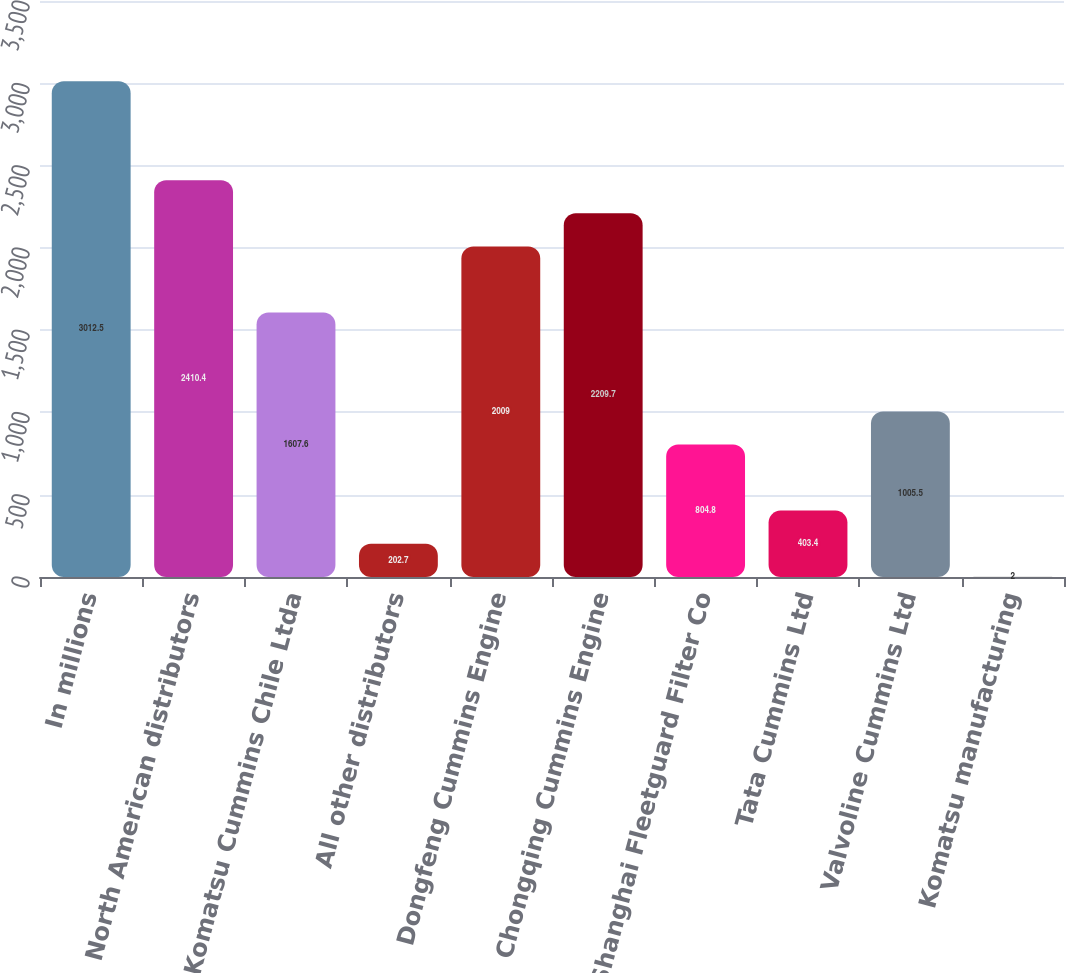Convert chart to OTSL. <chart><loc_0><loc_0><loc_500><loc_500><bar_chart><fcel>In millions<fcel>North American distributors<fcel>Komatsu Cummins Chile Ltda<fcel>All other distributors<fcel>Dongfeng Cummins Engine<fcel>Chongqing Cummins Engine<fcel>Shanghai Fleetguard Filter Co<fcel>Tata Cummins Ltd<fcel>Valvoline Cummins Ltd<fcel>Komatsu manufacturing<nl><fcel>3012.5<fcel>2410.4<fcel>1607.6<fcel>202.7<fcel>2009<fcel>2209.7<fcel>804.8<fcel>403.4<fcel>1005.5<fcel>2<nl></chart> 